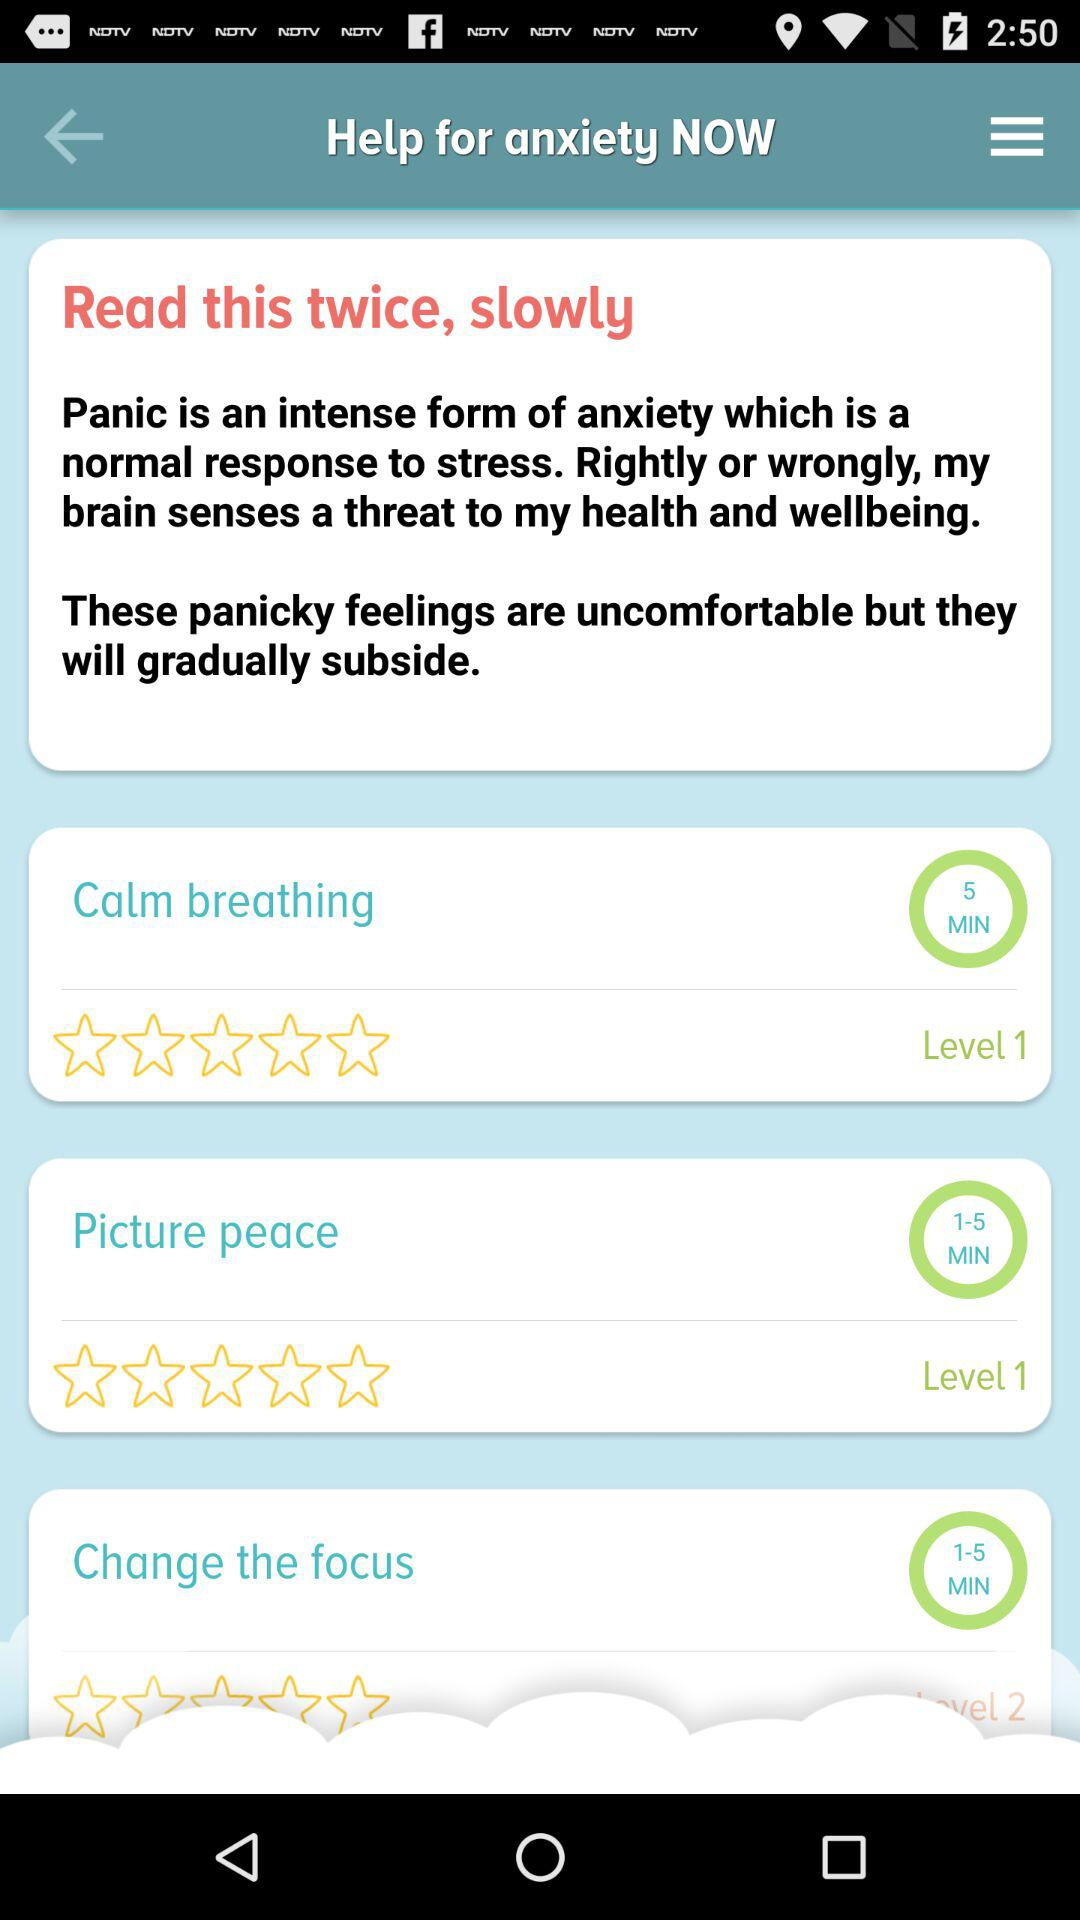What is the duration of calm breathing? The duration of calm breathing is 5 minutes. 